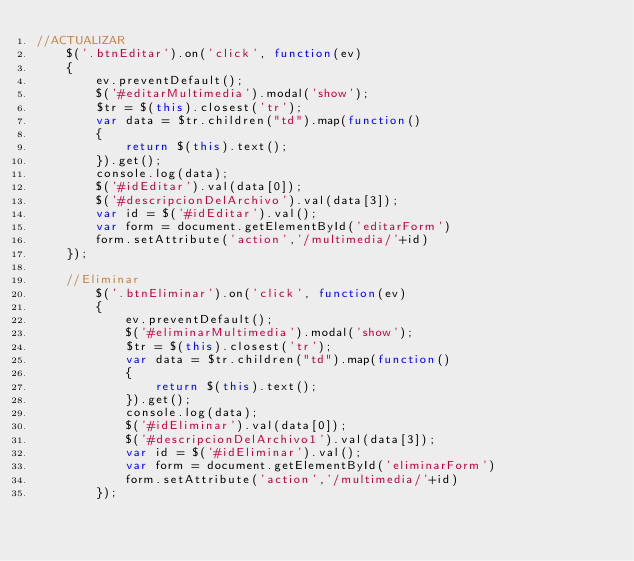<code> <loc_0><loc_0><loc_500><loc_500><_JavaScript_>//ACTUALIZAR
    $('.btnEditar').on('click', function(ev)
    {
        ev.preventDefault();
        $('#editarMultimedia').modal('show');
        $tr = $(this).closest('tr');
        var data = $tr.children("td").map(function()
        {
            return $(this).text();
        }).get();
        console.log(data);
        $('#idEditar').val(data[0]);
        $('#descripcionDelArchivo').val(data[3]);
        var id = $('#idEditar').val();
        var form = document.getElementById('editarForm')
        form.setAttribute('action','/multimedia/'+id)
    });

    //Eliminar
        $('.btnEliminar').on('click', function(ev)
        {
            ev.preventDefault();
            $('#eliminarMultimedia').modal('show');
            $tr = $(this).closest('tr');
            var data = $tr.children("td").map(function()
            {
                return $(this).text();
            }).get();
            console.log(data);
            $('#idEliminar').val(data[0]);
            $('#descripcionDelArchivo1').val(data[3]);
            var id = $('#idEliminar').val();
            var form = document.getElementById('eliminarForm')
            form.setAttribute('action','/multimedia/'+id)
        });
</code> 